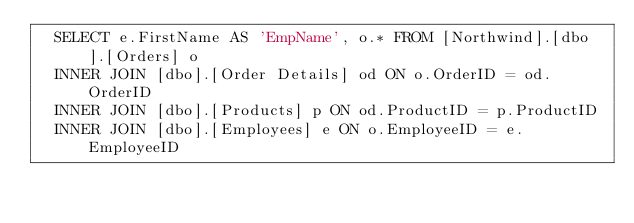Convert code to text. <code><loc_0><loc_0><loc_500><loc_500><_SQL_>  SELECT e.FirstName AS 'EmpName', o.* FROM [Northwind].[dbo].[Orders] o 
  INNER JOIN [dbo].[Order Details] od ON o.OrderID = od.OrderID
  INNER JOIN [dbo].[Products] p ON od.ProductID = p.ProductID
  INNER JOIN [dbo].[Employees] e ON o.EmployeeID = e.EmployeeID</code> 